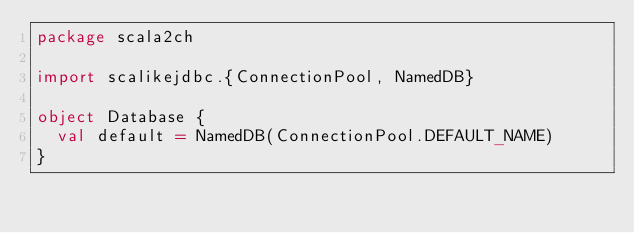Convert code to text. <code><loc_0><loc_0><loc_500><loc_500><_Scala_>package scala2ch

import scalikejdbc.{ConnectionPool, NamedDB}

object Database {
  val default = NamedDB(ConnectionPool.DEFAULT_NAME)
}
</code> 